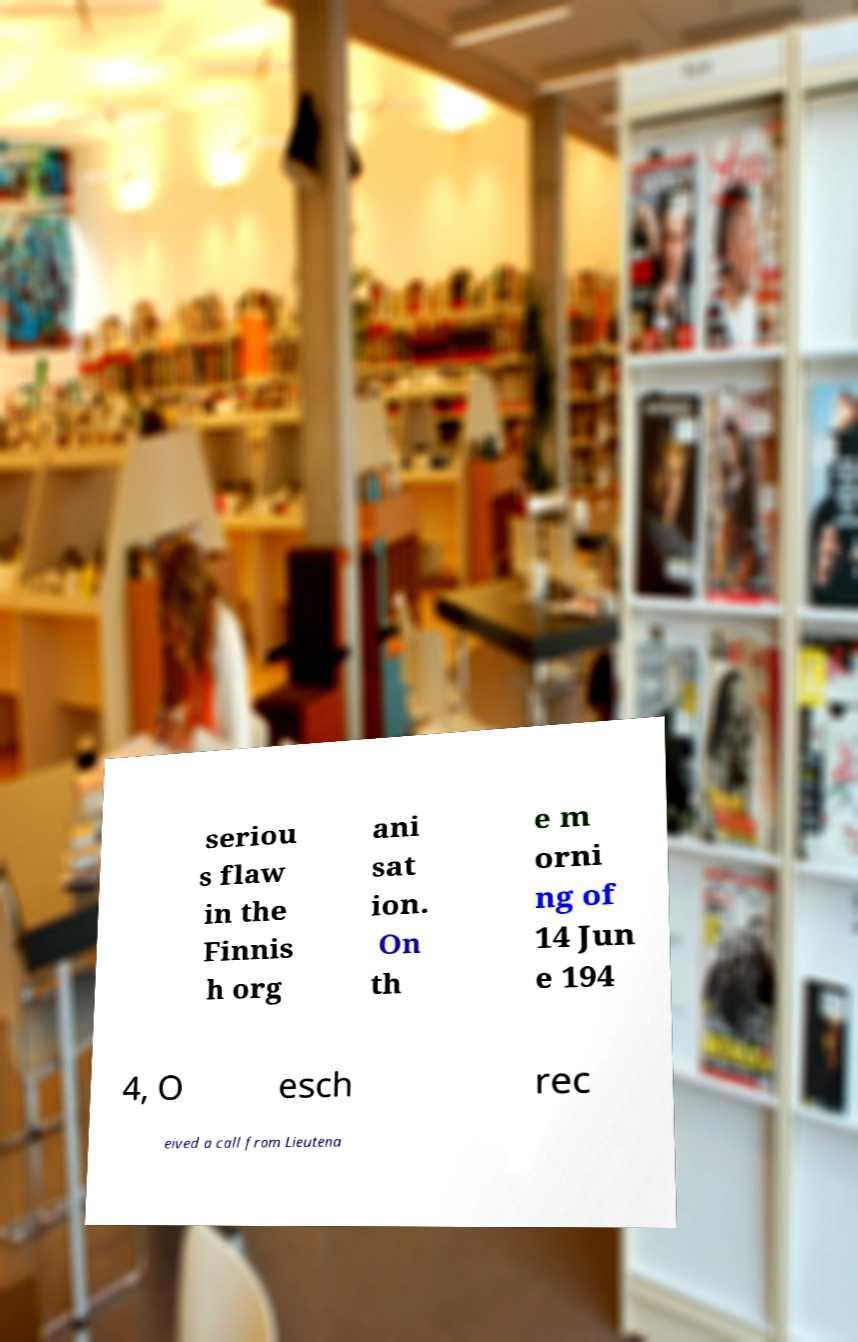Can you read and provide the text displayed in the image?This photo seems to have some interesting text. Can you extract and type it out for me? seriou s flaw in the Finnis h org ani sat ion. On th e m orni ng of 14 Jun e 194 4, O esch rec eived a call from Lieutena 